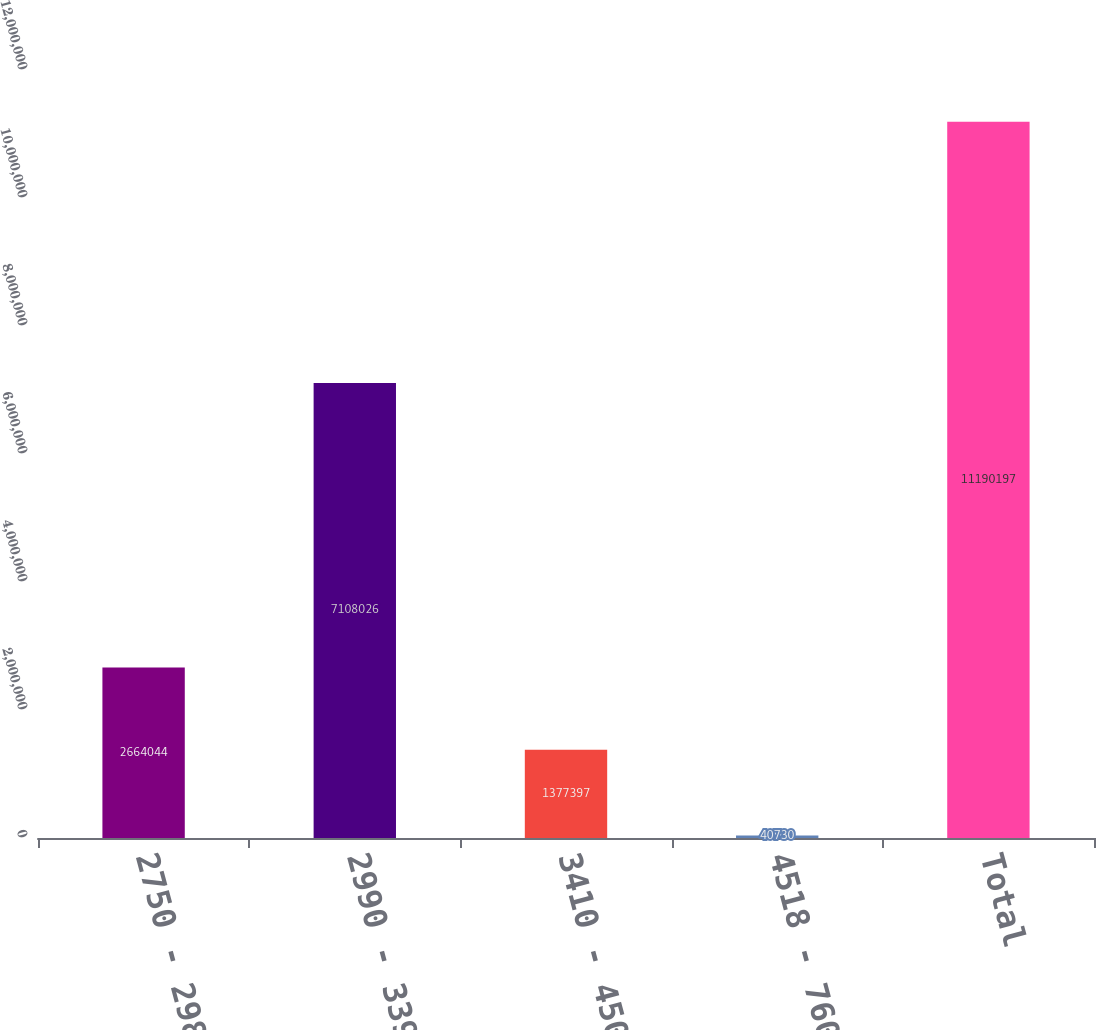Convert chart. <chart><loc_0><loc_0><loc_500><loc_500><bar_chart><fcel>2750 - 2981<fcel>2990 - 3395<fcel>3410 - 4500<fcel>4518 - 7600<fcel>Total<nl><fcel>2.66404e+06<fcel>7.10803e+06<fcel>1.3774e+06<fcel>40730<fcel>1.11902e+07<nl></chart> 